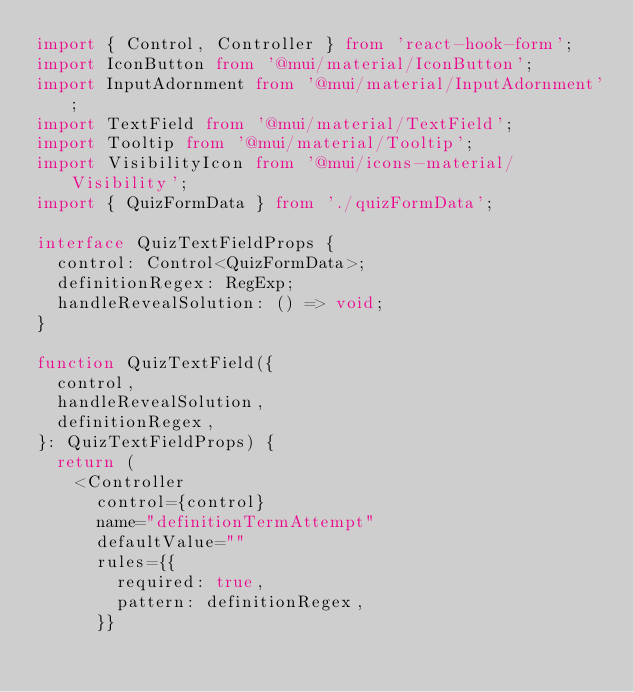<code> <loc_0><loc_0><loc_500><loc_500><_TypeScript_>import { Control, Controller } from 'react-hook-form';
import IconButton from '@mui/material/IconButton';
import InputAdornment from '@mui/material/InputAdornment';
import TextField from '@mui/material/TextField';
import Tooltip from '@mui/material/Tooltip';
import VisibilityIcon from '@mui/icons-material/Visibility';
import { QuizFormData } from './quizFormData';

interface QuizTextFieldProps {
  control: Control<QuizFormData>;
  definitionRegex: RegExp;
  handleRevealSolution: () => void;
}

function QuizTextField({
  control,
  handleRevealSolution,
  definitionRegex,
}: QuizTextFieldProps) {
  return (
    <Controller
      control={control}
      name="definitionTermAttempt"
      defaultValue=""
      rules={{
        required: true,
        pattern: definitionRegex,
      }}</code> 